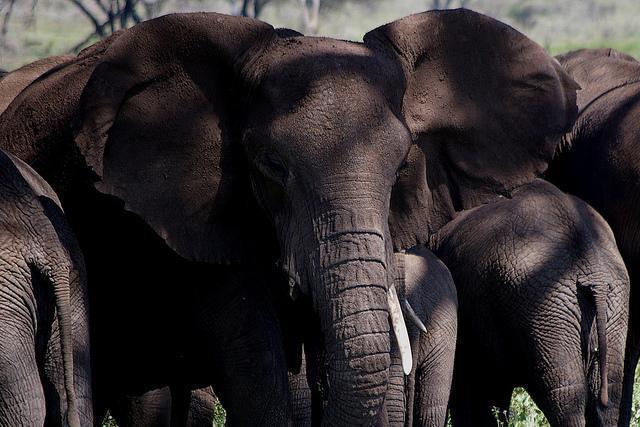What type of elephant is in the image?
From the following set of four choices, select the accurate answer to respond to the question.
Options: Stuffed, adult, baby, dead. Adult. 